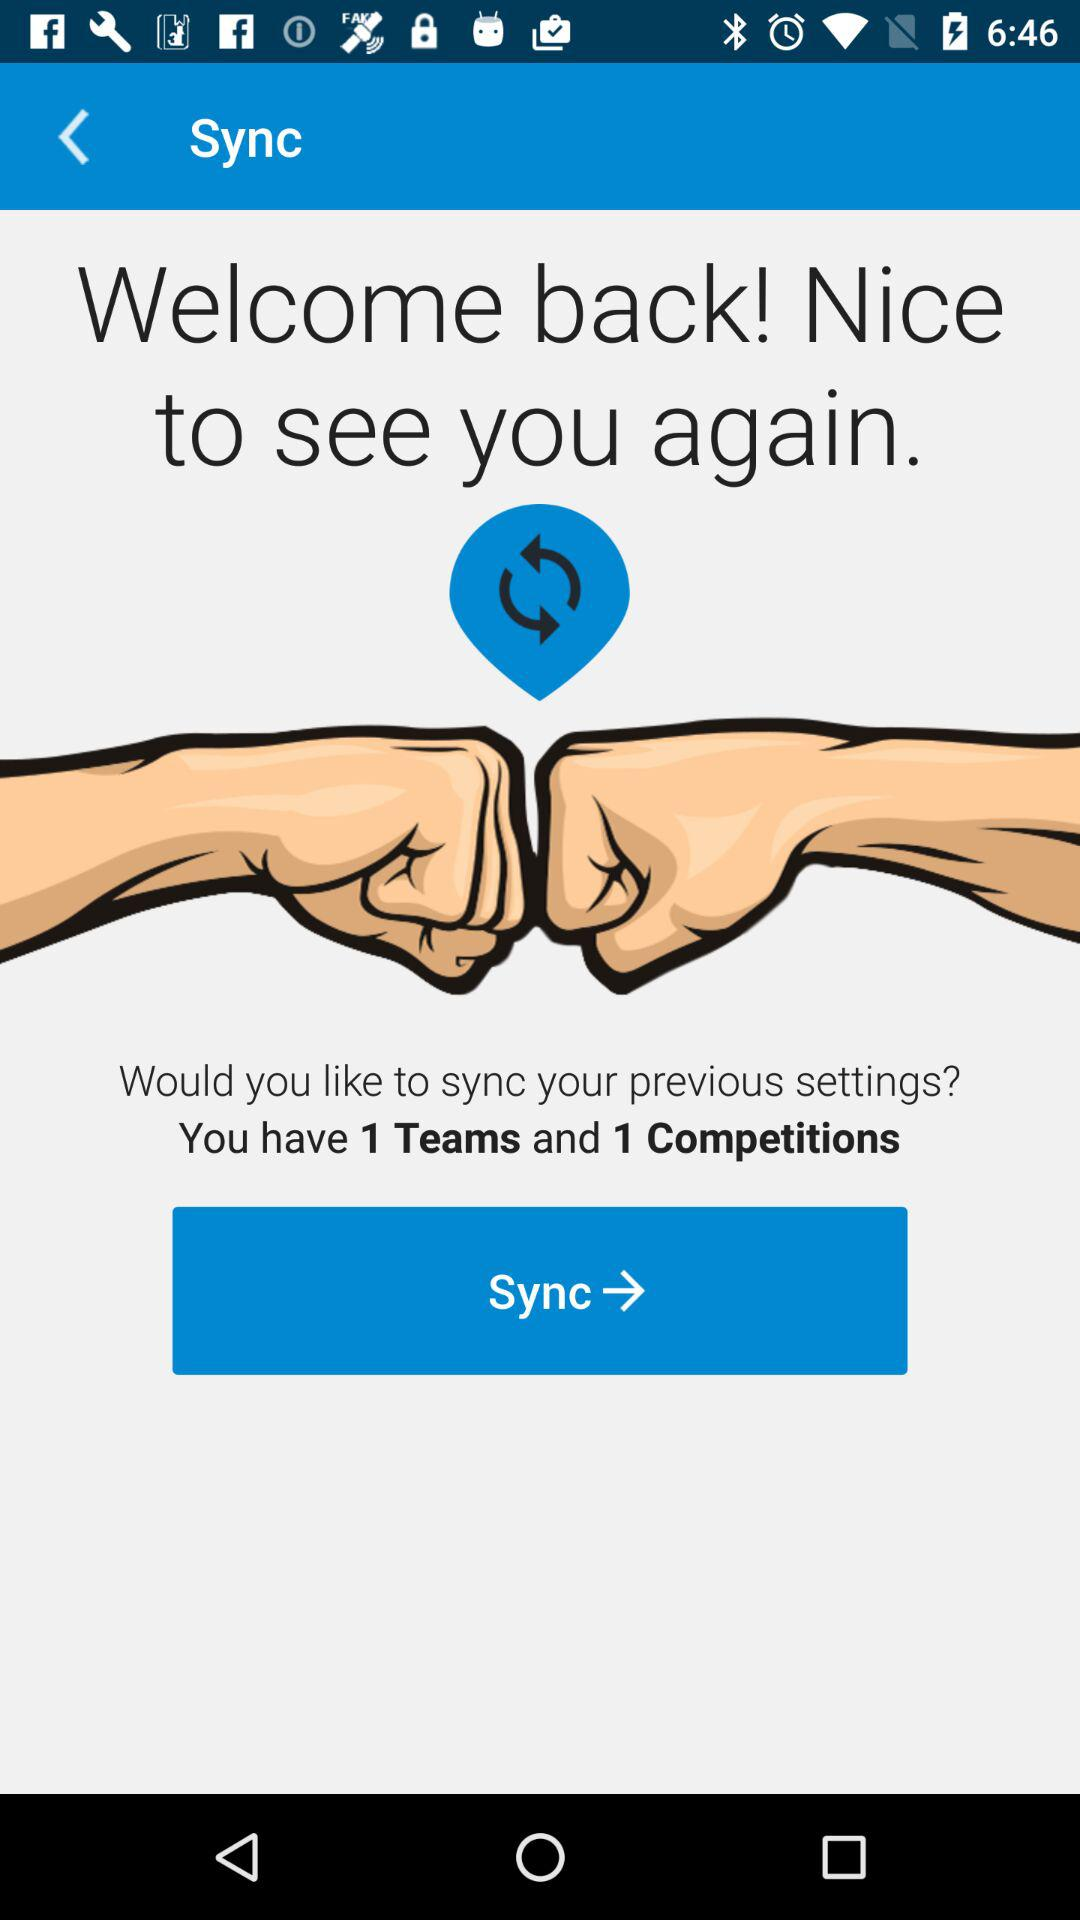How many teams and competitions are there? There is 1 team and 1 competition. 